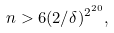<formula> <loc_0><loc_0><loc_500><loc_500>n > 6 ( 2 / \delta ) ^ { 2 ^ { 2 0 } } ,</formula> 